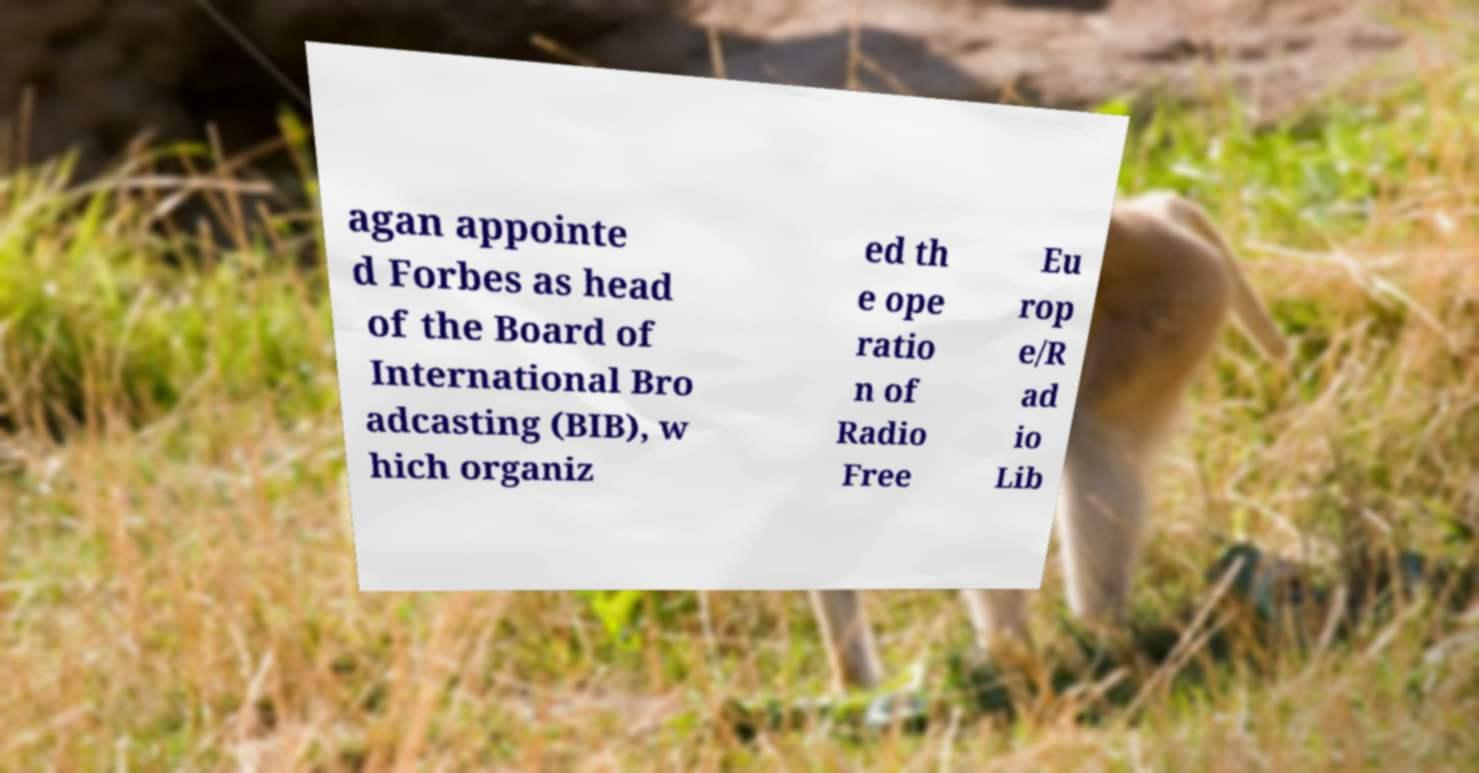Can you accurately transcribe the text from the provided image for me? agan appointe d Forbes as head of the Board of International Bro adcasting (BIB), w hich organiz ed th e ope ratio n of Radio Free Eu rop e/R ad io Lib 